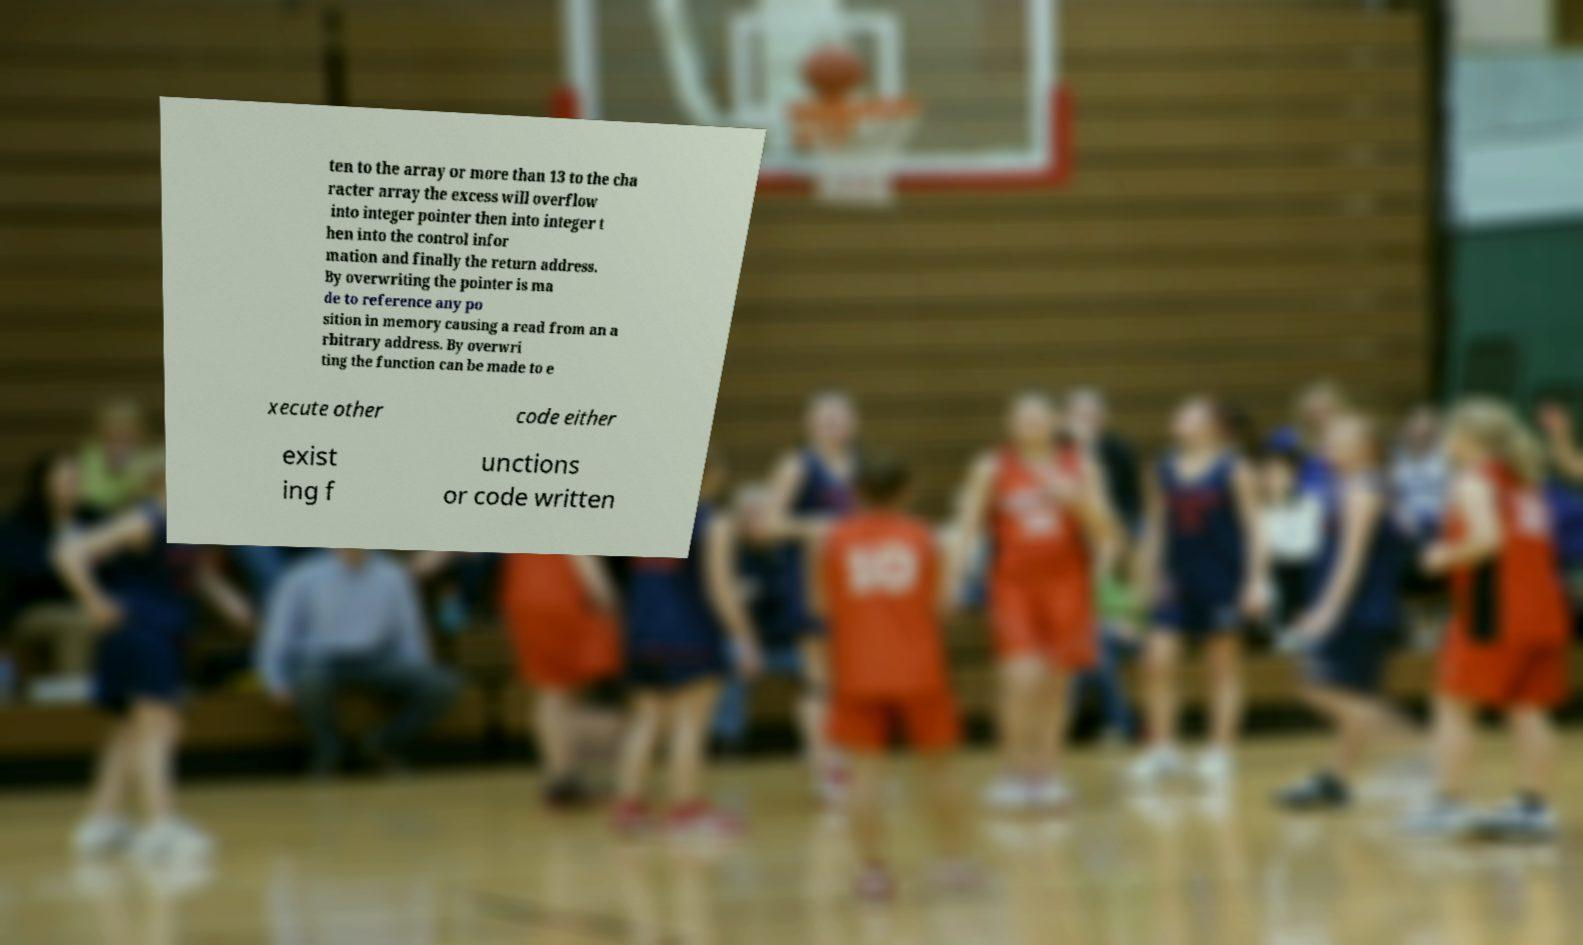Please read and relay the text visible in this image. What does it say? ten to the array or more than 13 to the cha racter array the excess will overflow into integer pointer then into integer t hen into the control infor mation and finally the return address. By overwriting the pointer is ma de to reference any po sition in memory causing a read from an a rbitrary address. By overwri ting the function can be made to e xecute other code either exist ing f unctions or code written 